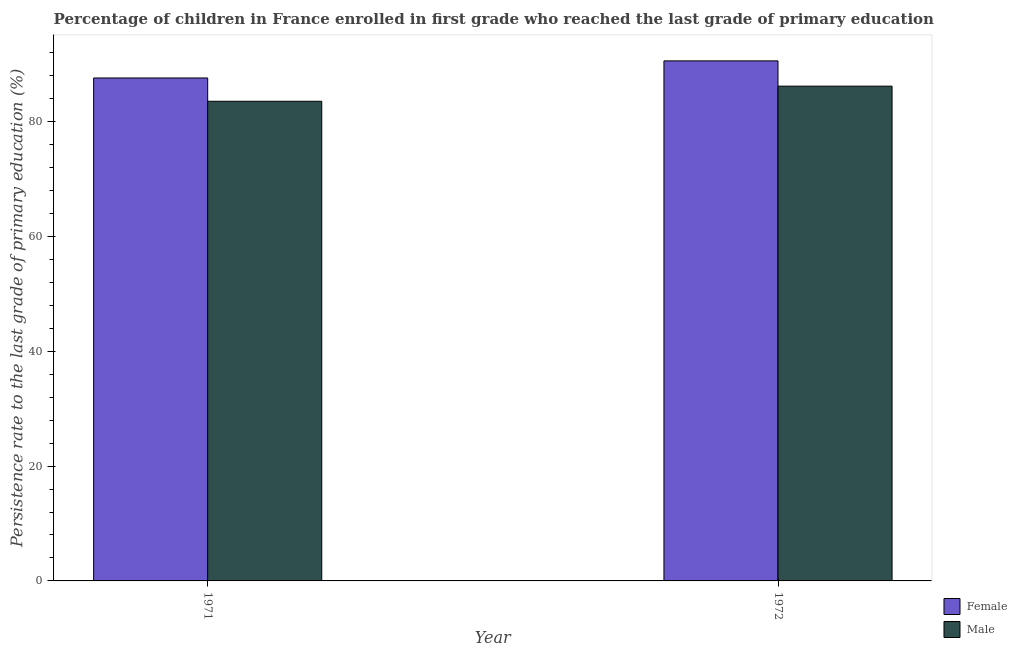How many different coloured bars are there?
Your response must be concise. 2. Are the number of bars per tick equal to the number of legend labels?
Offer a terse response. Yes. Are the number of bars on each tick of the X-axis equal?
Give a very brief answer. Yes. What is the label of the 1st group of bars from the left?
Your answer should be very brief. 1971. What is the persistence rate of male students in 1971?
Offer a very short reply. 83.52. Across all years, what is the maximum persistence rate of male students?
Ensure brevity in your answer.  86.16. Across all years, what is the minimum persistence rate of female students?
Your response must be concise. 87.58. In which year was the persistence rate of male students maximum?
Provide a succinct answer. 1972. What is the total persistence rate of male students in the graph?
Give a very brief answer. 169.68. What is the difference between the persistence rate of female students in 1971 and that in 1972?
Your response must be concise. -2.98. What is the difference between the persistence rate of female students in 1971 and the persistence rate of male students in 1972?
Offer a terse response. -2.98. What is the average persistence rate of male students per year?
Your answer should be compact. 84.84. What is the ratio of the persistence rate of female students in 1971 to that in 1972?
Keep it short and to the point. 0.97. In how many years, is the persistence rate of female students greater than the average persistence rate of female students taken over all years?
Your answer should be very brief. 1. How many bars are there?
Keep it short and to the point. 4. Are all the bars in the graph horizontal?
Make the answer very short. No. What is the difference between two consecutive major ticks on the Y-axis?
Your answer should be very brief. 20. Are the values on the major ticks of Y-axis written in scientific E-notation?
Your answer should be very brief. No. Does the graph contain any zero values?
Keep it short and to the point. No. Does the graph contain grids?
Keep it short and to the point. No. Where does the legend appear in the graph?
Make the answer very short. Bottom right. How many legend labels are there?
Your answer should be compact. 2. What is the title of the graph?
Provide a succinct answer. Percentage of children in France enrolled in first grade who reached the last grade of primary education. Does "Females" appear as one of the legend labels in the graph?
Give a very brief answer. No. What is the label or title of the Y-axis?
Give a very brief answer. Persistence rate to the last grade of primary education (%). What is the Persistence rate to the last grade of primary education (%) in Female in 1971?
Keep it short and to the point. 87.58. What is the Persistence rate to the last grade of primary education (%) of Male in 1971?
Your answer should be very brief. 83.52. What is the Persistence rate to the last grade of primary education (%) in Female in 1972?
Your answer should be compact. 90.56. What is the Persistence rate to the last grade of primary education (%) of Male in 1972?
Provide a succinct answer. 86.16. Across all years, what is the maximum Persistence rate to the last grade of primary education (%) of Female?
Provide a succinct answer. 90.56. Across all years, what is the maximum Persistence rate to the last grade of primary education (%) of Male?
Provide a succinct answer. 86.16. Across all years, what is the minimum Persistence rate to the last grade of primary education (%) of Female?
Offer a terse response. 87.58. Across all years, what is the minimum Persistence rate to the last grade of primary education (%) of Male?
Ensure brevity in your answer.  83.52. What is the total Persistence rate to the last grade of primary education (%) of Female in the graph?
Your response must be concise. 178.14. What is the total Persistence rate to the last grade of primary education (%) of Male in the graph?
Provide a short and direct response. 169.68. What is the difference between the Persistence rate to the last grade of primary education (%) of Female in 1971 and that in 1972?
Your answer should be very brief. -2.98. What is the difference between the Persistence rate to the last grade of primary education (%) in Male in 1971 and that in 1972?
Provide a succinct answer. -2.63. What is the difference between the Persistence rate to the last grade of primary education (%) of Female in 1971 and the Persistence rate to the last grade of primary education (%) of Male in 1972?
Your answer should be compact. 1.42. What is the average Persistence rate to the last grade of primary education (%) in Female per year?
Give a very brief answer. 89.07. What is the average Persistence rate to the last grade of primary education (%) of Male per year?
Give a very brief answer. 84.84. In the year 1971, what is the difference between the Persistence rate to the last grade of primary education (%) in Female and Persistence rate to the last grade of primary education (%) in Male?
Ensure brevity in your answer.  4.06. In the year 1972, what is the difference between the Persistence rate to the last grade of primary education (%) in Female and Persistence rate to the last grade of primary education (%) in Male?
Make the answer very short. 4.4. What is the ratio of the Persistence rate to the last grade of primary education (%) of Female in 1971 to that in 1972?
Your answer should be compact. 0.97. What is the ratio of the Persistence rate to the last grade of primary education (%) of Male in 1971 to that in 1972?
Offer a very short reply. 0.97. What is the difference between the highest and the second highest Persistence rate to the last grade of primary education (%) in Female?
Offer a terse response. 2.98. What is the difference between the highest and the second highest Persistence rate to the last grade of primary education (%) in Male?
Your answer should be compact. 2.63. What is the difference between the highest and the lowest Persistence rate to the last grade of primary education (%) of Female?
Make the answer very short. 2.98. What is the difference between the highest and the lowest Persistence rate to the last grade of primary education (%) of Male?
Make the answer very short. 2.63. 